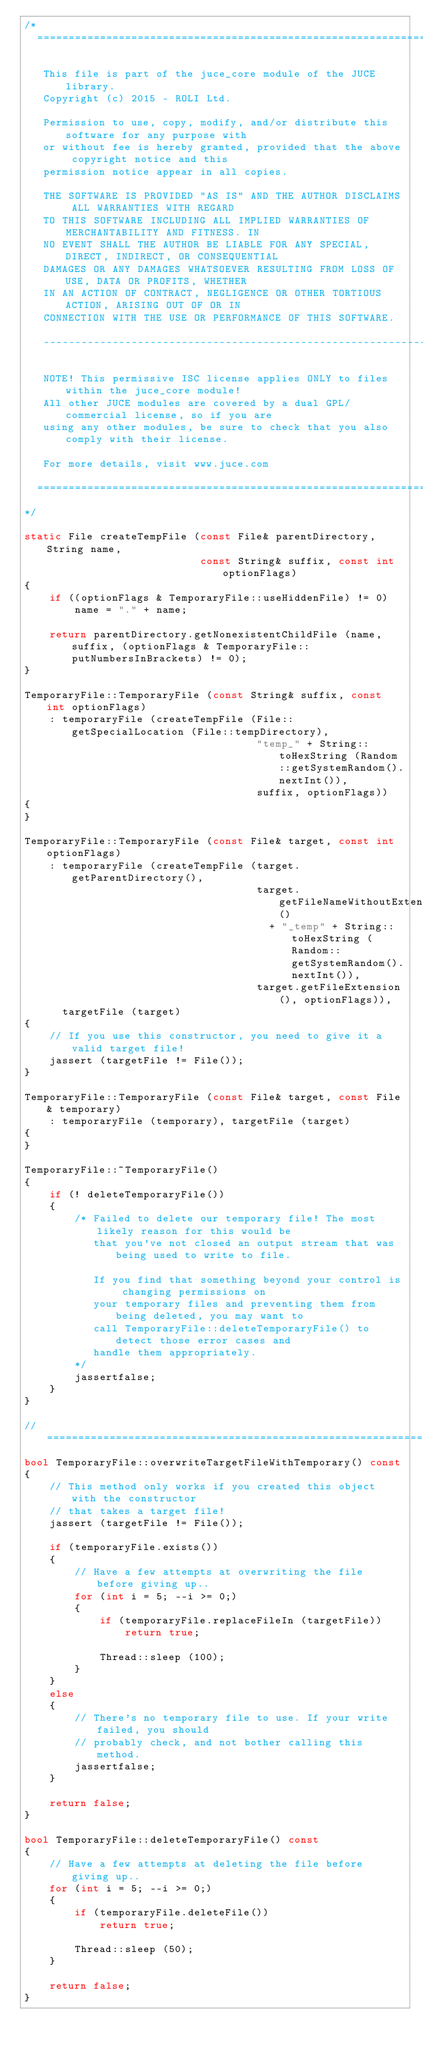<code> <loc_0><loc_0><loc_500><loc_500><_C++_>/*
  ==============================================================================

   This file is part of the juce_core module of the JUCE library.
   Copyright (c) 2015 - ROLI Ltd.

   Permission to use, copy, modify, and/or distribute this software for any purpose with
   or without fee is hereby granted, provided that the above copyright notice and this
   permission notice appear in all copies.

   THE SOFTWARE IS PROVIDED "AS IS" AND THE AUTHOR DISCLAIMS ALL WARRANTIES WITH REGARD
   TO THIS SOFTWARE INCLUDING ALL IMPLIED WARRANTIES OF MERCHANTABILITY AND FITNESS. IN
   NO EVENT SHALL THE AUTHOR BE LIABLE FOR ANY SPECIAL, DIRECT, INDIRECT, OR CONSEQUENTIAL
   DAMAGES OR ANY DAMAGES WHATSOEVER RESULTING FROM LOSS OF USE, DATA OR PROFITS, WHETHER
   IN AN ACTION OF CONTRACT, NEGLIGENCE OR OTHER TORTIOUS ACTION, ARISING OUT OF OR IN
   CONNECTION WITH THE USE OR PERFORMANCE OF THIS SOFTWARE.

   ------------------------------------------------------------------------------

   NOTE! This permissive ISC license applies ONLY to files within the juce_core module!
   All other JUCE modules are covered by a dual GPL/commercial license, so if you are
   using any other modules, be sure to check that you also comply with their license.

   For more details, visit www.juce.com

  ==============================================================================
*/

static File createTempFile (const File& parentDirectory, String name,
                            const String& suffix, const int optionFlags)
{
    if ((optionFlags & TemporaryFile::useHiddenFile) != 0)
        name = "." + name;

    return parentDirectory.getNonexistentChildFile (name, suffix, (optionFlags & TemporaryFile::putNumbersInBrackets) != 0);
}

TemporaryFile::TemporaryFile (const String& suffix, const int optionFlags)
    : temporaryFile (createTempFile (File::getSpecialLocation (File::tempDirectory),
                                     "temp_" + String::toHexString (Random::getSystemRandom().nextInt()),
                                     suffix, optionFlags))
{
}

TemporaryFile::TemporaryFile (const File& target, const int optionFlags)
    : temporaryFile (createTempFile (target.getParentDirectory(),
                                     target.getFileNameWithoutExtension()
                                       + "_temp" + String::toHexString (Random::getSystemRandom().nextInt()),
                                     target.getFileExtension(), optionFlags)),
      targetFile (target)
{
    // If you use this constructor, you need to give it a valid target file!
    jassert (targetFile != File());
}

TemporaryFile::TemporaryFile (const File& target, const File& temporary)
    : temporaryFile (temporary), targetFile (target)
{
}

TemporaryFile::~TemporaryFile()
{
    if (! deleteTemporaryFile())
    {
        /* Failed to delete our temporary file! The most likely reason for this would be
           that you've not closed an output stream that was being used to write to file.

           If you find that something beyond your control is changing permissions on
           your temporary files and preventing them from being deleted, you may want to
           call TemporaryFile::deleteTemporaryFile() to detect those error cases and
           handle them appropriately.
        */
        jassertfalse;
    }
}

//==============================================================================
bool TemporaryFile::overwriteTargetFileWithTemporary() const
{
    // This method only works if you created this object with the constructor
    // that takes a target file!
    jassert (targetFile != File());

    if (temporaryFile.exists())
    {
        // Have a few attempts at overwriting the file before giving up..
        for (int i = 5; --i >= 0;)
        {
            if (temporaryFile.replaceFileIn (targetFile))
                return true;

            Thread::sleep (100);
        }
    }
    else
    {
        // There's no temporary file to use. If your write failed, you should
        // probably check, and not bother calling this method.
        jassertfalse;
    }

    return false;
}

bool TemporaryFile::deleteTemporaryFile() const
{
    // Have a few attempts at deleting the file before giving up..
    for (int i = 5; --i >= 0;)
    {
        if (temporaryFile.deleteFile())
            return true;

        Thread::sleep (50);
    }

    return false;
}
</code> 